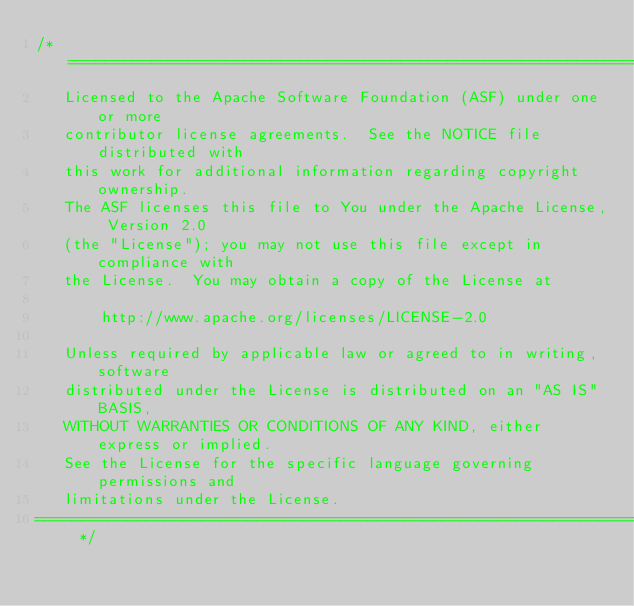Convert code to text. <code><loc_0><loc_0><loc_500><loc_500><_Java_>/* ====================================================================
   Licensed to the Apache Software Foundation (ASF) under one or more
   contributor license agreements.  See the NOTICE file distributed with
   this work for additional information regarding copyright ownership.
   The ASF licenses this file to You under the Apache License, Version 2.0
   (the "License"); you may not use this file except in compliance with
   the License.  You may obtain a copy of the License at

       http://www.apache.org/licenses/LICENSE-2.0

   Unless required by applicable law or agreed to in writing, software
   distributed under the License is distributed on an "AS IS" BASIS,
   WITHOUT WARRANTIES OR CONDITIONS OF ANY KIND, either express or implied.
   See the License for the specific language governing permissions and
   limitations under the License.
==================================================================== */
</code> 